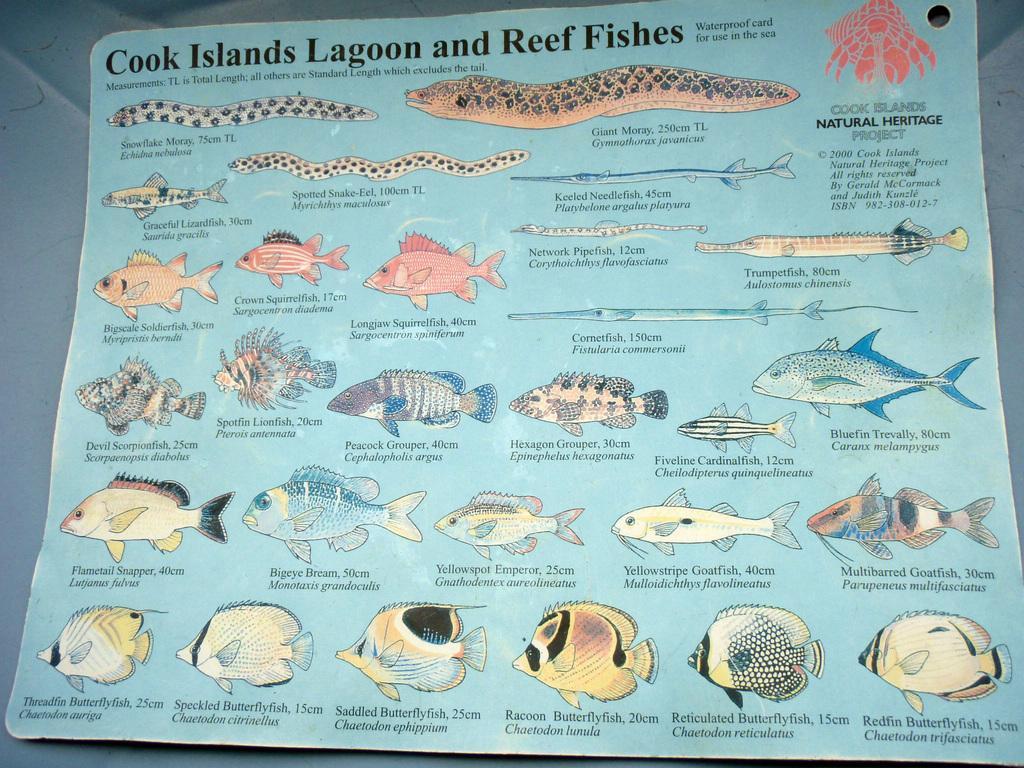Could you give a brief overview of what you see in this image? In this picture we can see a poster, in the poster we can find fish and some text. 